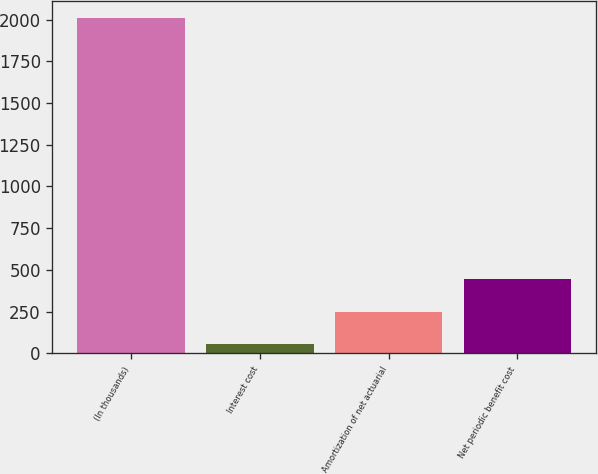Convert chart. <chart><loc_0><loc_0><loc_500><loc_500><bar_chart><fcel>(In thousands)<fcel>Interest cost<fcel>Amortization of net actuarial<fcel>Net periodic benefit cost<nl><fcel>2011<fcel>54<fcel>249.7<fcel>445.4<nl></chart> 